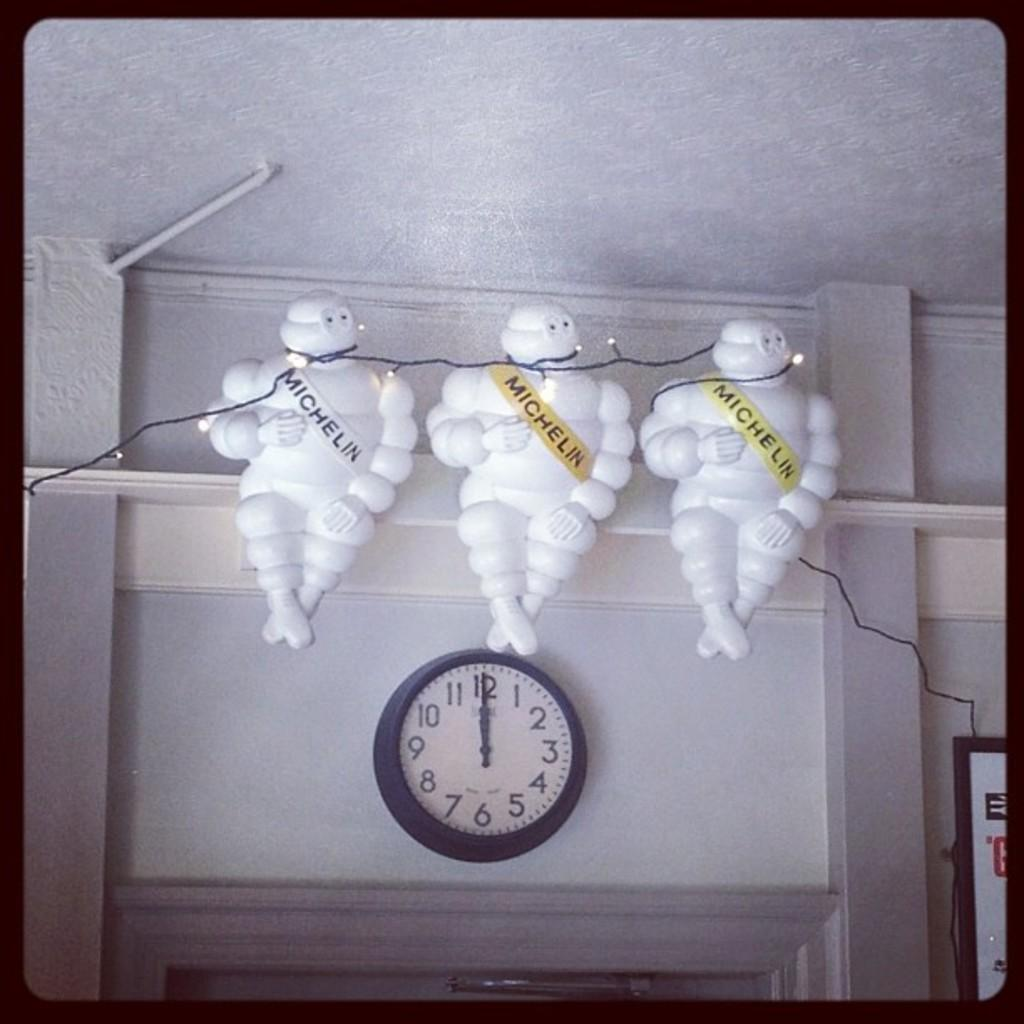<image>
Relay a brief, clear account of the picture shown. Three Michelin men sit above a clock that has the time of 12:00. 